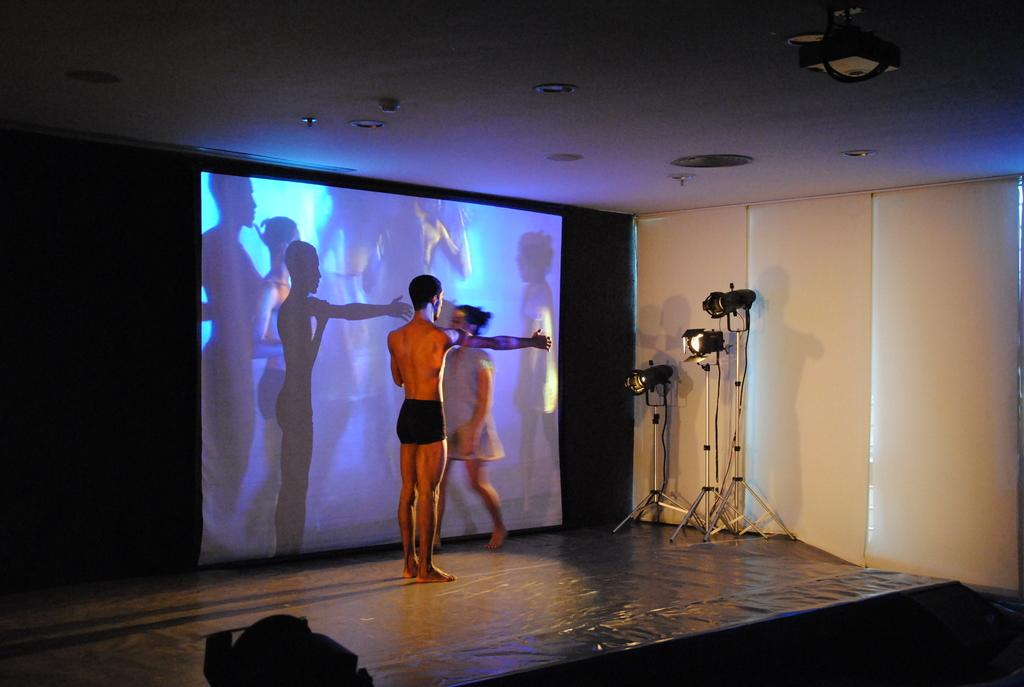Who are the two people in the image? There is a man and a woman in the image. Where are they located? They are standing on a stage. What is behind them? There is a screen behind them that shows the reflection of people. What else can be seen in the image? There are stands with lights in the image. How many geese are flying over the stage in the image? There are no geese visible in the image; it features a man and a woman standing on a stage with a screen and lights. 